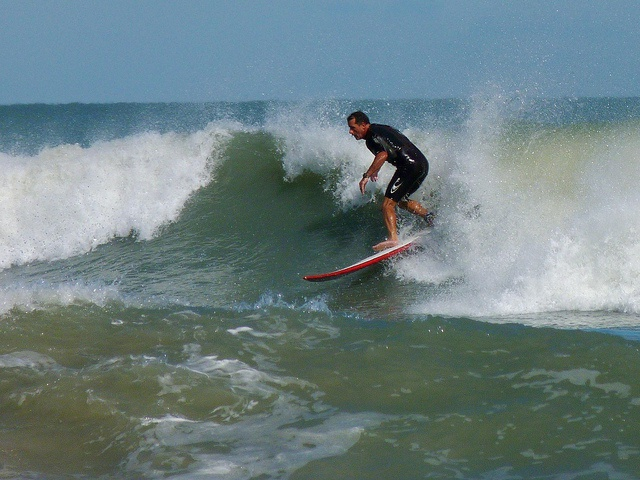Describe the objects in this image and their specific colors. I can see people in gray, black, maroon, and brown tones and surfboard in gray, darkgray, brown, and black tones in this image. 